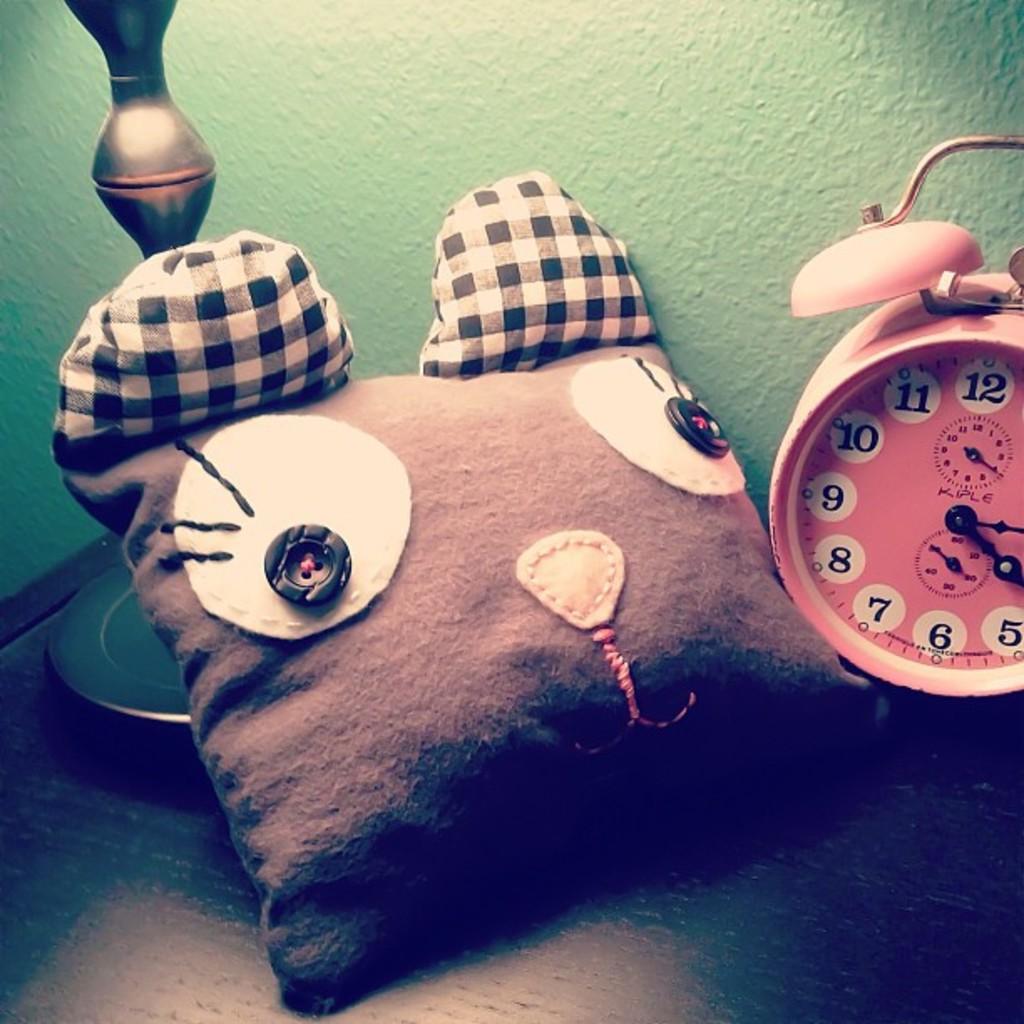What numbers can be seen on the clock?
Your response must be concise. 5, 6, 7, 8, 9, 10, 11, 12. 